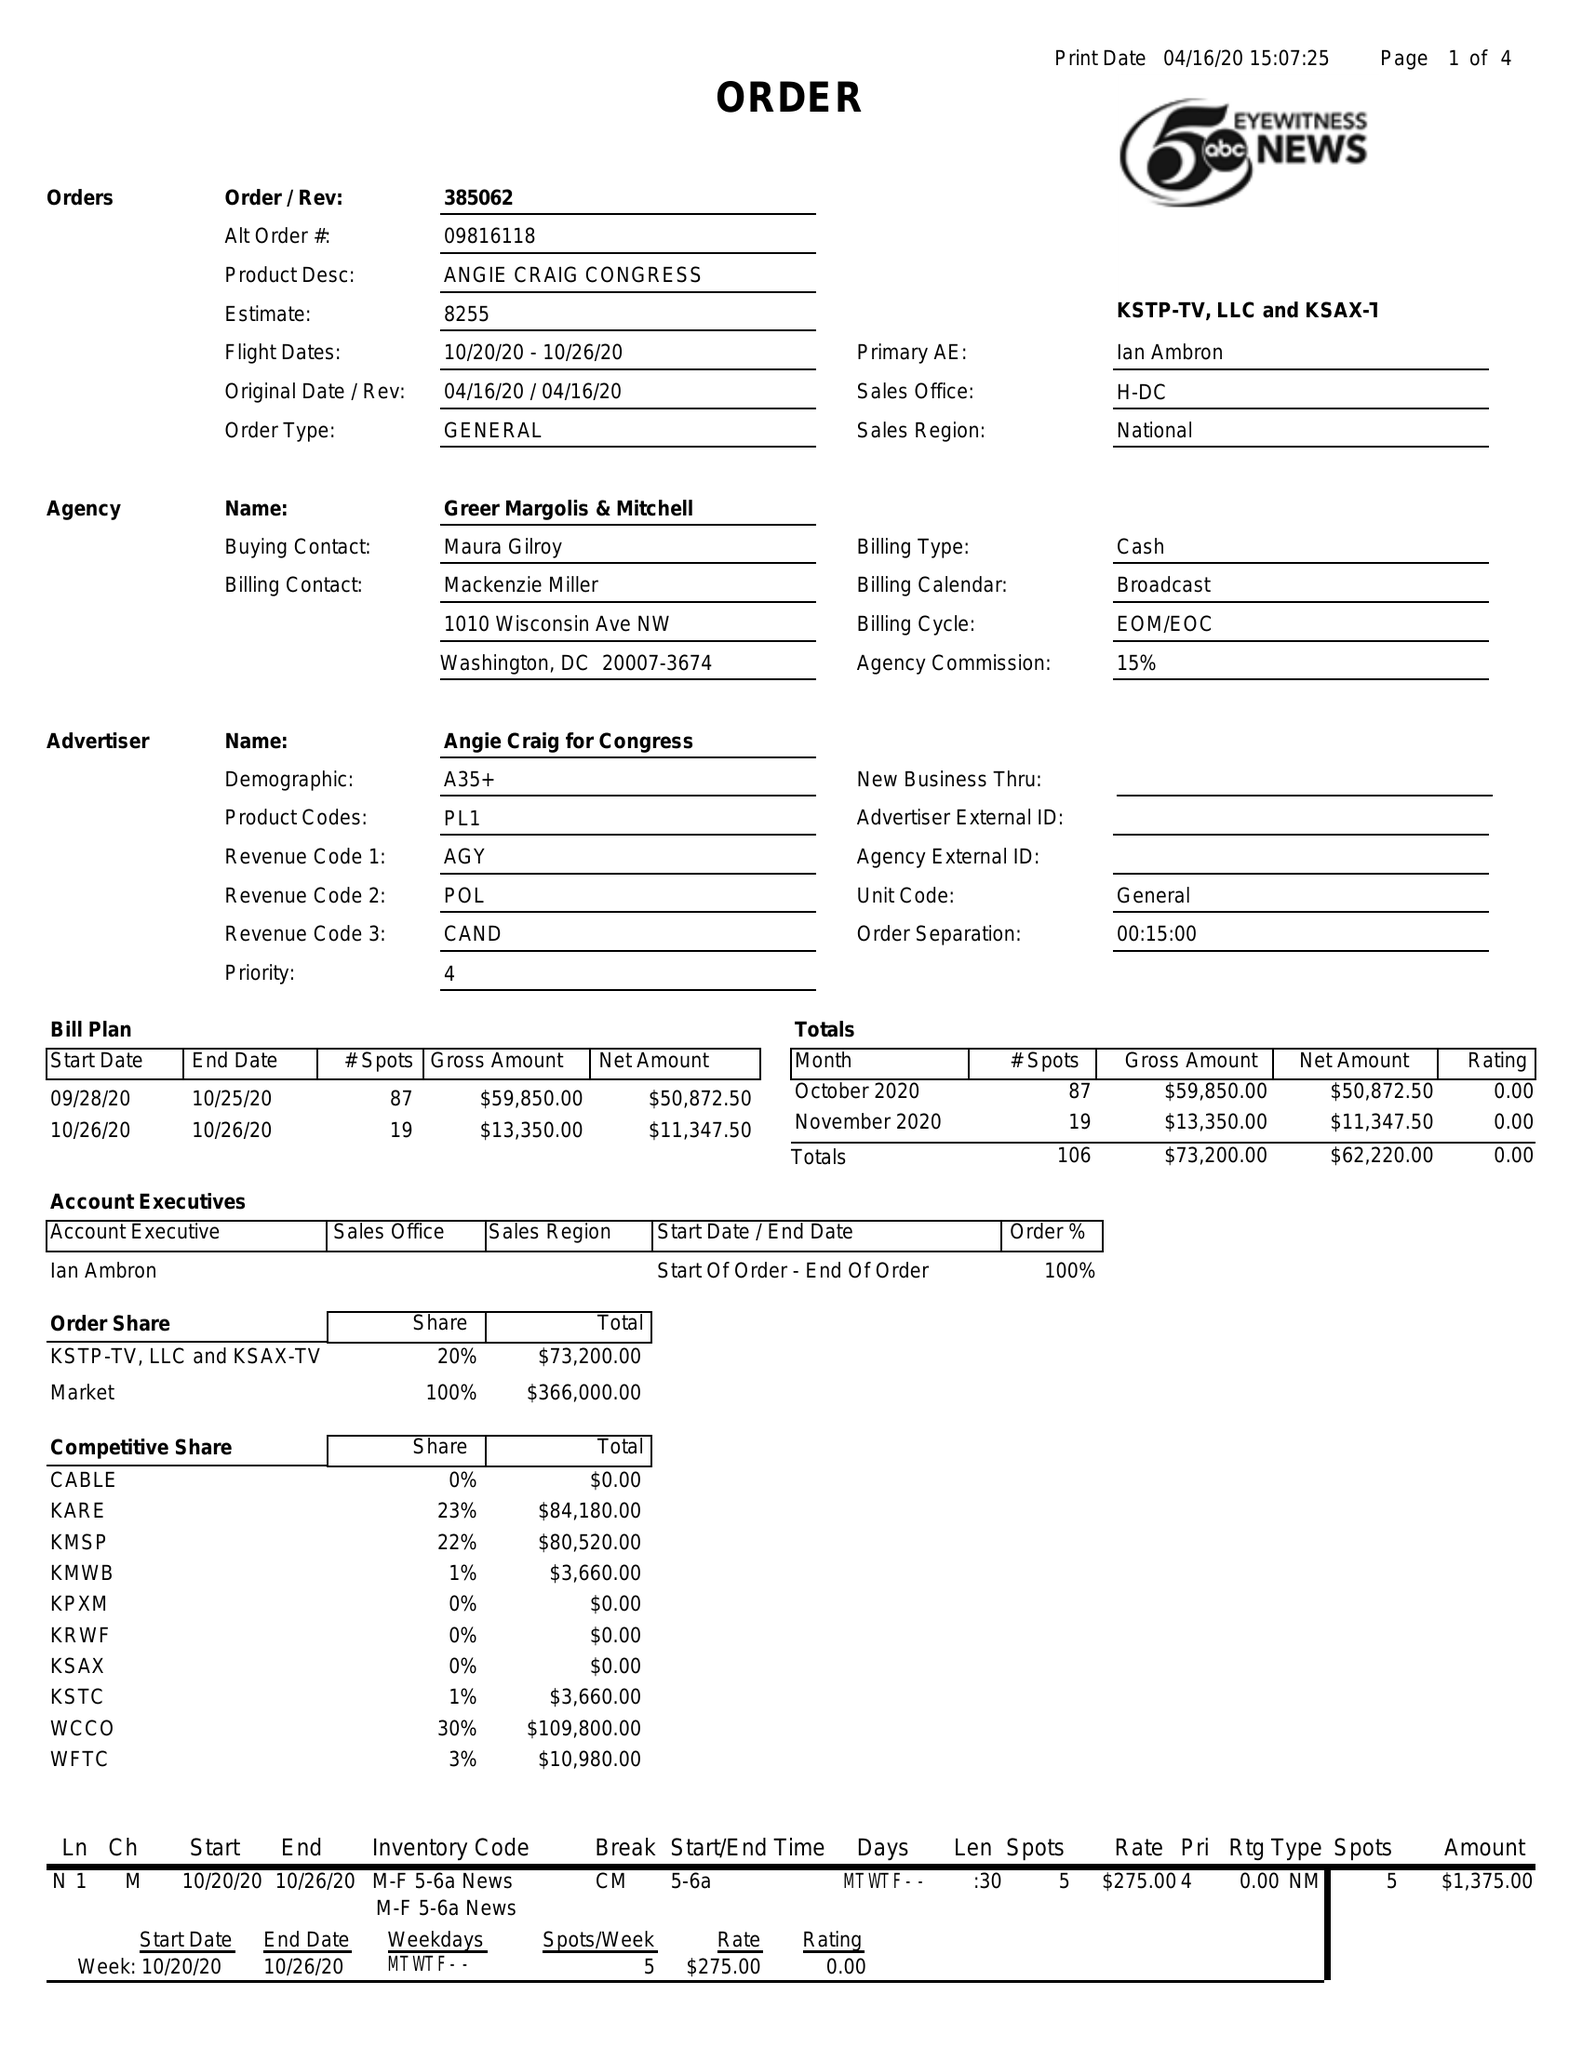What is the value for the flight_to?
Answer the question using a single word or phrase. 10/26/20 